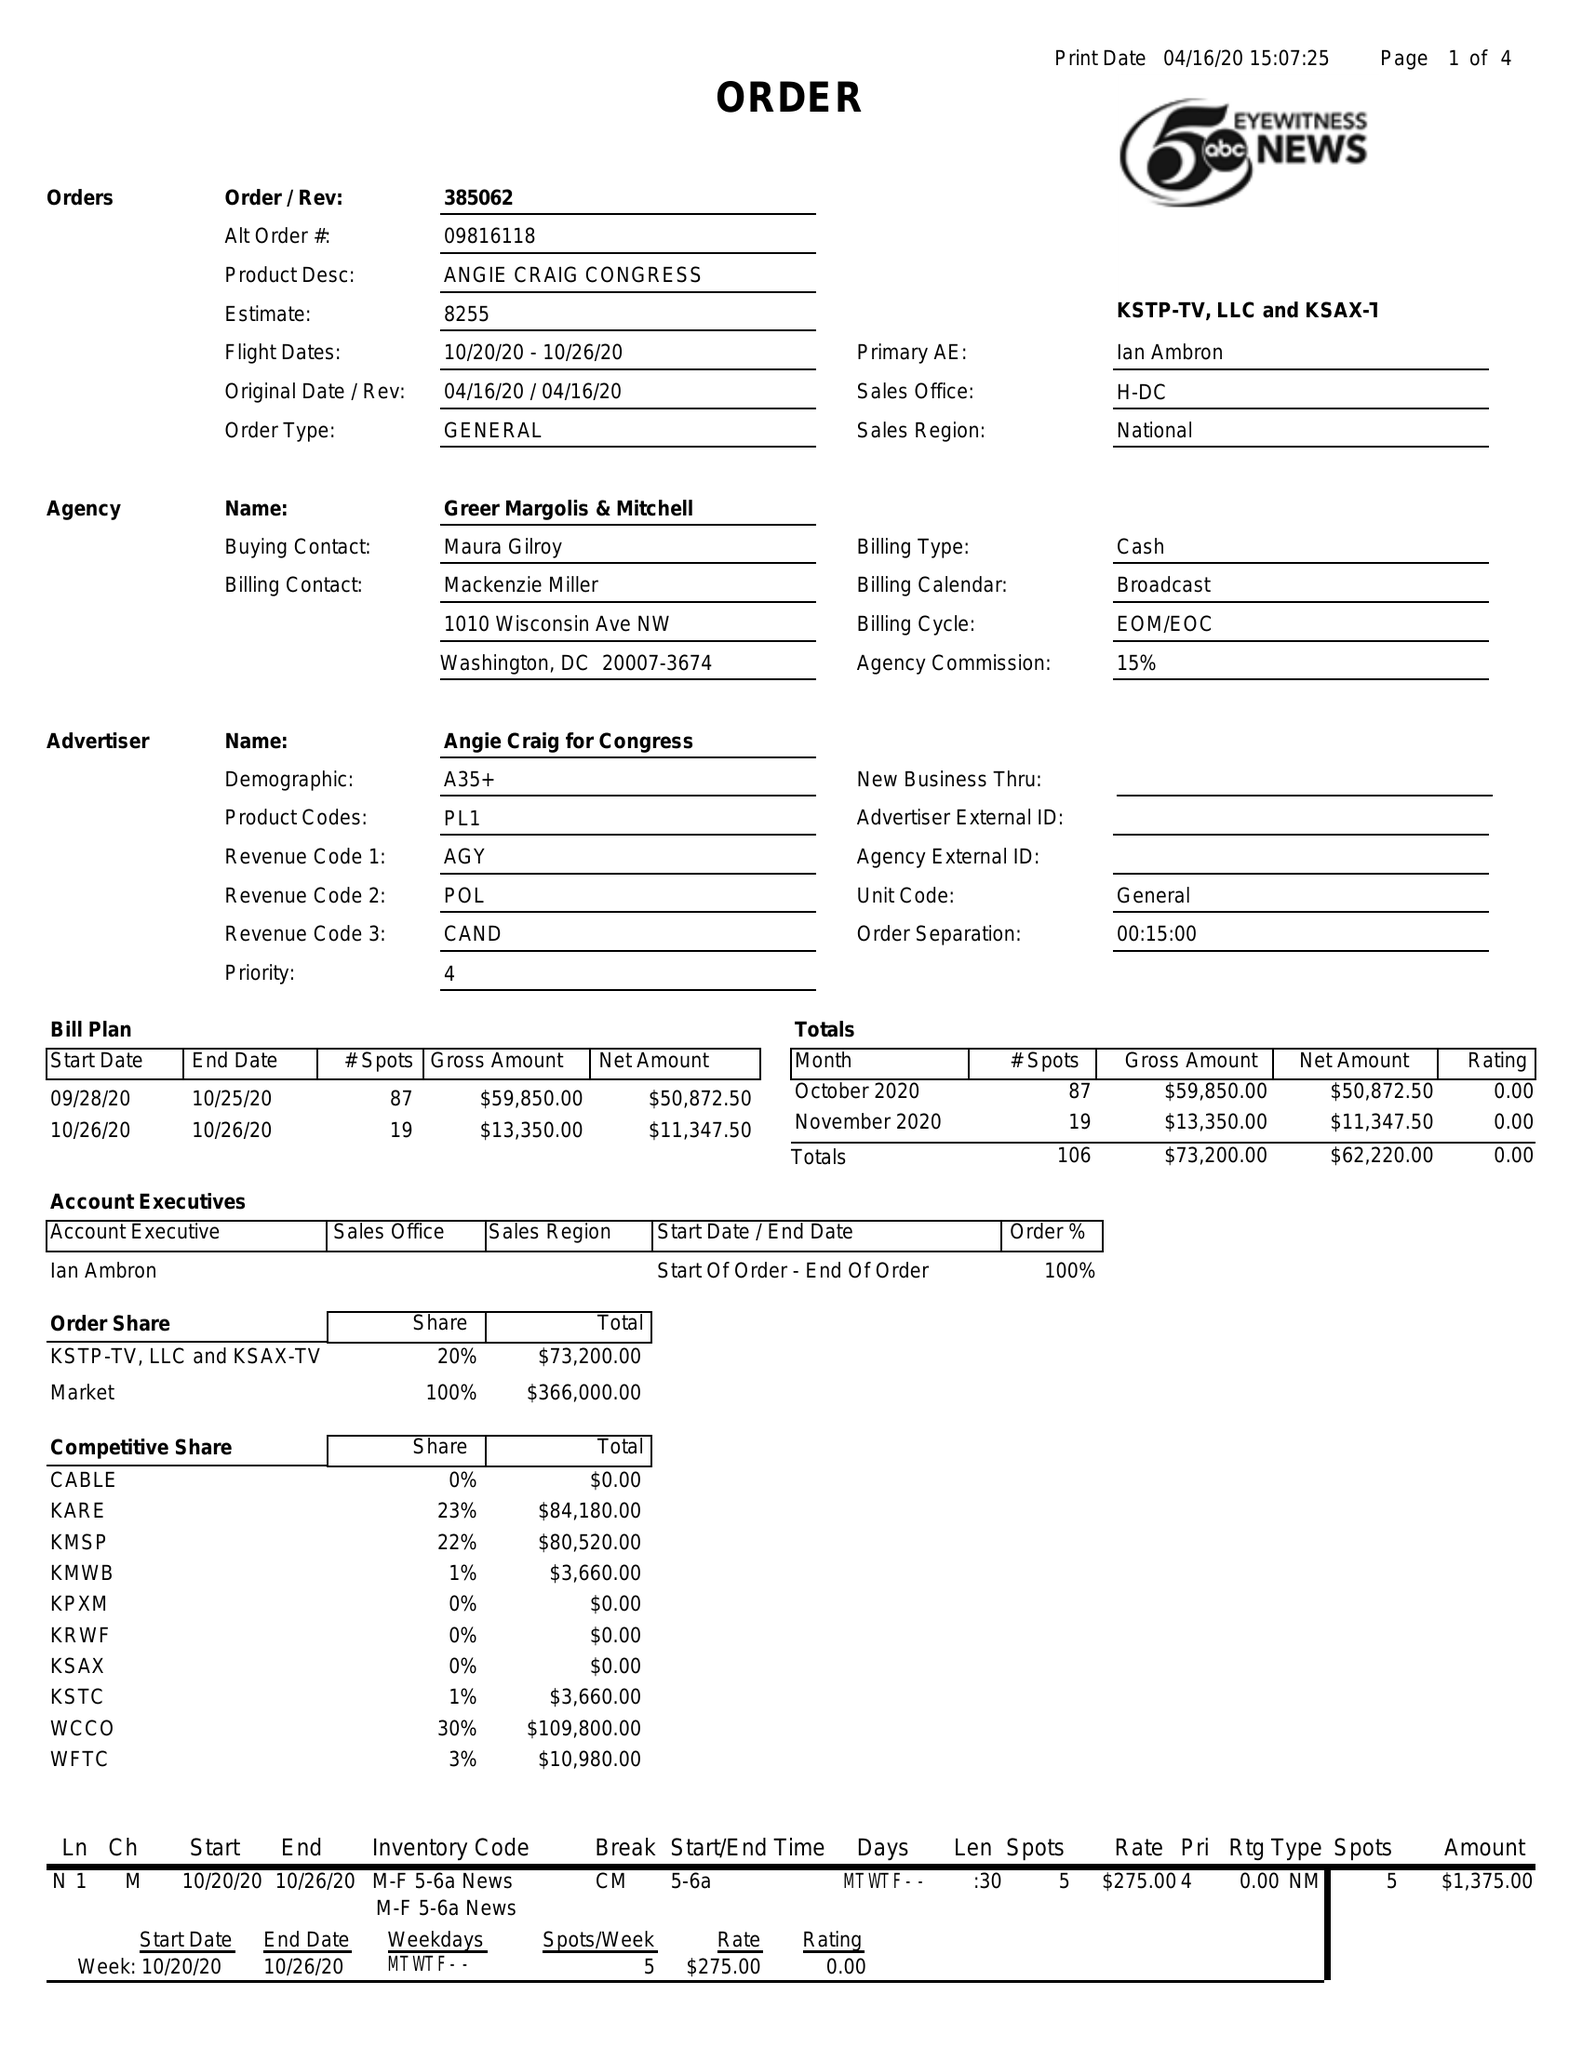What is the value for the flight_to?
Answer the question using a single word or phrase. 10/26/20 